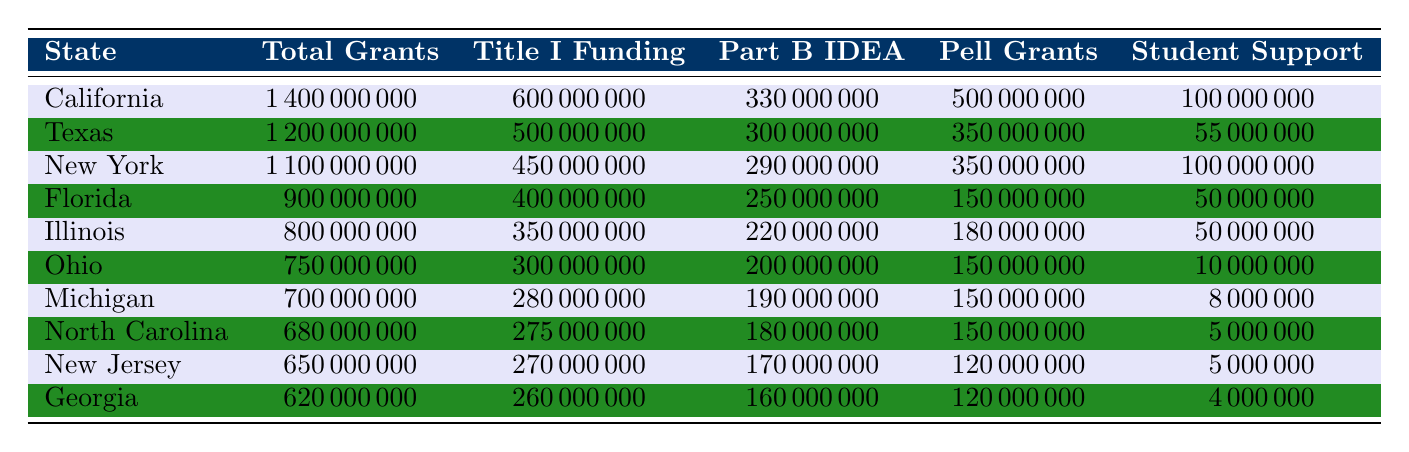What state received the highest total grants in 2021? From the table, we can see that California has the highest total grants amounting to 1,400,000,000.
Answer: California How much Title I funding did Texas receive? The table shows that Texas received 500,000,000 in Title I funding.
Answer: 500,000,000 Which state received the least amount in Student Support grants? By comparing the Student Support grants across all states in the table, Georgia received the least amount, which is 4,000,000.
Answer: Georgia What is the total funding for Part B IDEA across the top three states? Adding the Part B IDEA funding for California (330,000,000), Texas (300,000,000), and New York (290,000,000) gives us a total of 920,000,000.
Answer: 920,000,000 Did Illinois receive more Pell Grants than Ohio? Comparing the Pell Grants for both states, Illinois received 180,000,000 while Ohio received 150,000,000. Therefore, the statement is true.
Answer: Yes What is the average total grant amount for the states listed? To find the average, sum all total grants (1,400,000,000 + 1,200,000,000 + 1,100,000,000 + 900,000,000 + 800,000,000 + 750,000,000 + 700,000,000 + 680,000,000 + 650,000,000 + 620,000,000 = 8,570,000,000) and then divide by the number of states (10). The average total grant amount is 857,000,000.
Answer: 857,000,000 Which state has the highest Pell Grant amount, and how much is it? From the table, California has the highest Pell Grant amount with 500,000,000.
Answer: California, 500,000,000 If you combine the Title I funding and Pell Grants of New Jersey, what is the total? Adding New Jersey's Title I funding (270,000,000) and Pell Grants (120,000,000) gives us 390,000,000.
Answer: 390,000,000 How much more total funding did California receive compared to Georgia? The total grants for California are 1,400,000,000 and for Georgia are 620,000,000. The difference is 1,400,000,000 - 620,000,000 = 780,000,000.
Answer: 780,000,000 Is the total grant amount for North Carolina greater than the combined Title I and Part B IDEA funding for Florida? Florida's combined Title I and Part B IDEA funding is 400,000,000 + 250,000,000 = 650,000,000. North Carolina received 680,000,000 in total grants; hence the statement is true.
Answer: Yes What percentage of the total grants for Texas was allocated to Pell Grants? To find the percentage, divide Texas's Pell Grants (350,000,000) by the total grants (1,200,000,000) and multiply by 100, so (350,000,000 / 1,200,000,000) * 100 = 29.17%.
Answer: 29.17% 